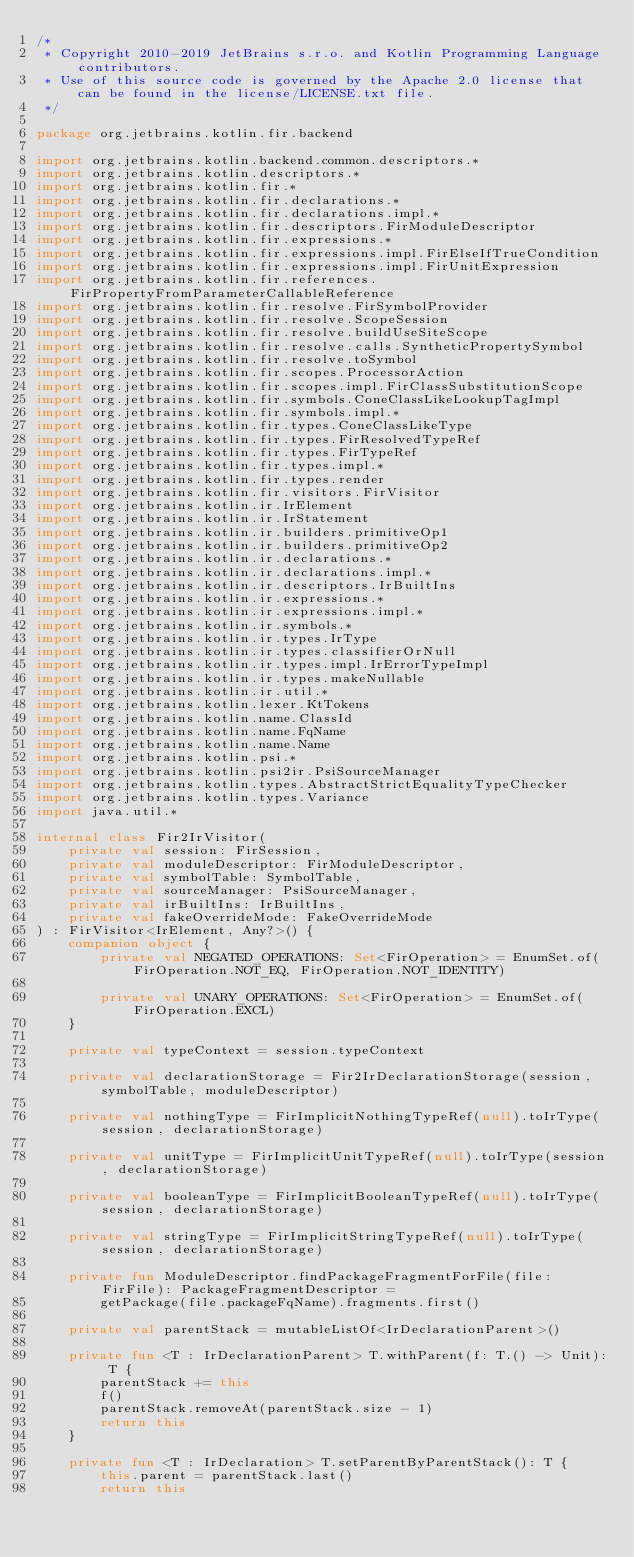Convert code to text. <code><loc_0><loc_0><loc_500><loc_500><_Kotlin_>/*
 * Copyright 2010-2019 JetBrains s.r.o. and Kotlin Programming Language contributors.
 * Use of this source code is governed by the Apache 2.0 license that can be found in the license/LICENSE.txt file.
 */

package org.jetbrains.kotlin.fir.backend

import org.jetbrains.kotlin.backend.common.descriptors.*
import org.jetbrains.kotlin.descriptors.*
import org.jetbrains.kotlin.fir.*
import org.jetbrains.kotlin.fir.declarations.*
import org.jetbrains.kotlin.fir.declarations.impl.*
import org.jetbrains.kotlin.fir.descriptors.FirModuleDescriptor
import org.jetbrains.kotlin.fir.expressions.*
import org.jetbrains.kotlin.fir.expressions.impl.FirElseIfTrueCondition
import org.jetbrains.kotlin.fir.expressions.impl.FirUnitExpression
import org.jetbrains.kotlin.fir.references.FirPropertyFromParameterCallableReference
import org.jetbrains.kotlin.fir.resolve.FirSymbolProvider
import org.jetbrains.kotlin.fir.resolve.ScopeSession
import org.jetbrains.kotlin.fir.resolve.buildUseSiteScope
import org.jetbrains.kotlin.fir.resolve.calls.SyntheticPropertySymbol
import org.jetbrains.kotlin.fir.resolve.toSymbol
import org.jetbrains.kotlin.fir.scopes.ProcessorAction
import org.jetbrains.kotlin.fir.scopes.impl.FirClassSubstitutionScope
import org.jetbrains.kotlin.fir.symbols.ConeClassLikeLookupTagImpl
import org.jetbrains.kotlin.fir.symbols.impl.*
import org.jetbrains.kotlin.fir.types.ConeClassLikeType
import org.jetbrains.kotlin.fir.types.FirResolvedTypeRef
import org.jetbrains.kotlin.fir.types.FirTypeRef
import org.jetbrains.kotlin.fir.types.impl.*
import org.jetbrains.kotlin.fir.types.render
import org.jetbrains.kotlin.fir.visitors.FirVisitor
import org.jetbrains.kotlin.ir.IrElement
import org.jetbrains.kotlin.ir.IrStatement
import org.jetbrains.kotlin.ir.builders.primitiveOp1
import org.jetbrains.kotlin.ir.builders.primitiveOp2
import org.jetbrains.kotlin.ir.declarations.*
import org.jetbrains.kotlin.ir.declarations.impl.*
import org.jetbrains.kotlin.ir.descriptors.IrBuiltIns
import org.jetbrains.kotlin.ir.expressions.*
import org.jetbrains.kotlin.ir.expressions.impl.*
import org.jetbrains.kotlin.ir.symbols.*
import org.jetbrains.kotlin.ir.types.IrType
import org.jetbrains.kotlin.ir.types.classifierOrNull
import org.jetbrains.kotlin.ir.types.impl.IrErrorTypeImpl
import org.jetbrains.kotlin.ir.types.makeNullable
import org.jetbrains.kotlin.ir.util.*
import org.jetbrains.kotlin.lexer.KtTokens
import org.jetbrains.kotlin.name.ClassId
import org.jetbrains.kotlin.name.FqName
import org.jetbrains.kotlin.name.Name
import org.jetbrains.kotlin.psi.*
import org.jetbrains.kotlin.psi2ir.PsiSourceManager
import org.jetbrains.kotlin.types.AbstractStrictEqualityTypeChecker
import org.jetbrains.kotlin.types.Variance
import java.util.*

internal class Fir2IrVisitor(
    private val session: FirSession,
    private val moduleDescriptor: FirModuleDescriptor,
    private val symbolTable: SymbolTable,
    private val sourceManager: PsiSourceManager,
    private val irBuiltIns: IrBuiltIns,
    private val fakeOverrideMode: FakeOverrideMode
) : FirVisitor<IrElement, Any?>() {
    companion object {
        private val NEGATED_OPERATIONS: Set<FirOperation> = EnumSet.of(FirOperation.NOT_EQ, FirOperation.NOT_IDENTITY)

        private val UNARY_OPERATIONS: Set<FirOperation> = EnumSet.of(FirOperation.EXCL)
    }

    private val typeContext = session.typeContext

    private val declarationStorage = Fir2IrDeclarationStorage(session, symbolTable, moduleDescriptor)

    private val nothingType = FirImplicitNothingTypeRef(null).toIrType(session, declarationStorage)

    private val unitType = FirImplicitUnitTypeRef(null).toIrType(session, declarationStorage)

    private val booleanType = FirImplicitBooleanTypeRef(null).toIrType(session, declarationStorage)

    private val stringType = FirImplicitStringTypeRef(null).toIrType(session, declarationStorage)

    private fun ModuleDescriptor.findPackageFragmentForFile(file: FirFile): PackageFragmentDescriptor =
        getPackage(file.packageFqName).fragments.first()

    private val parentStack = mutableListOf<IrDeclarationParent>()

    private fun <T : IrDeclarationParent> T.withParent(f: T.() -> Unit): T {
        parentStack += this
        f()
        parentStack.removeAt(parentStack.size - 1)
        return this
    }

    private fun <T : IrDeclaration> T.setParentByParentStack(): T {
        this.parent = parentStack.last()
        return this</code> 